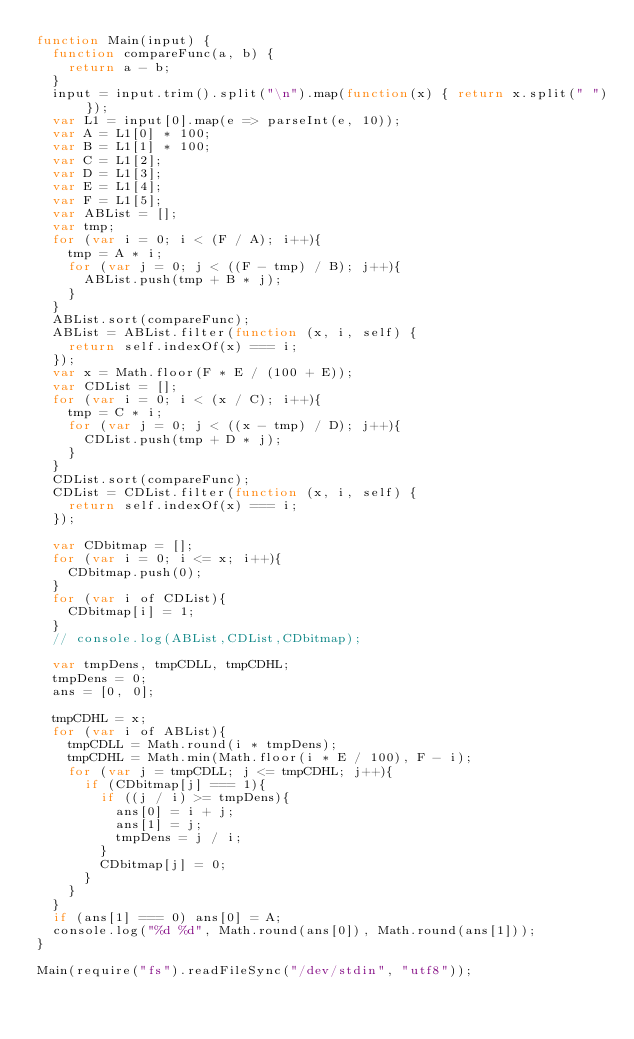Convert code to text. <code><loc_0><loc_0><loc_500><loc_500><_JavaScript_>function Main(input) {
	function compareFunc(a, b) {
		return a - b;
	}
	input = input.trim().split("\n").map(function(x) { return x.split(" ")});
	var L1 = input[0].map(e => parseInt(e, 10));
	var A = L1[0] * 100;
	var B = L1[1] * 100;
	var C = L1[2];
	var D = L1[3];
	var E = L1[4];
	var F = L1[5];
	var ABList = [];
	var tmp;
	for (var i = 0; i < (F / A); i++){
		tmp = A * i;
		for (var j = 0; j < ((F - tmp) / B); j++){
			ABList.push(tmp + B * j);
		}
	}
	ABList.sort(compareFunc);
	ABList = ABList.filter(function (x, i, self) {
		return self.indexOf(x) === i;
	});
	var x = Math.floor(F * E / (100 + E));
	var CDList = [];
	for (var i = 0; i < (x / C); i++){
		tmp = C * i;
		for (var j = 0; j < ((x - tmp) / D); j++){
			CDList.push(tmp + D * j);
		}
	}
	CDList.sort(compareFunc);
	CDList = CDList.filter(function (x, i, self) {
		return self.indexOf(x) === i;
	});

	var CDbitmap = [];
	for (var i = 0; i <= x; i++){
		CDbitmap.push(0);
	}
	for (var i of CDList){
		CDbitmap[i] = 1;
	}
	// console.log(ABList,CDList,CDbitmap);

	var tmpDens, tmpCDLL, tmpCDHL;
	tmpDens = 0;
	ans = [0, 0];
	
	tmpCDHL = x;
	for (var i of ABList){
		tmpCDLL = Math.round(i * tmpDens);
		tmpCDHL = Math.min(Math.floor(i * E / 100), F - i);
		for (var j = tmpCDLL; j <= tmpCDHL; j++){
			if (CDbitmap[j] === 1){
				if ((j / i) >= tmpDens){
					ans[0] = i + j;
					ans[1] = j;
					tmpDens = j / i;
				}
				CDbitmap[j] = 0;
			}
		}
	}
	if (ans[1] === 0) ans[0] = A;
	console.log("%d %d", Math.round(ans[0]), Math.round(ans[1]));
}

Main(require("fs").readFileSync("/dev/stdin", "utf8")); </code> 